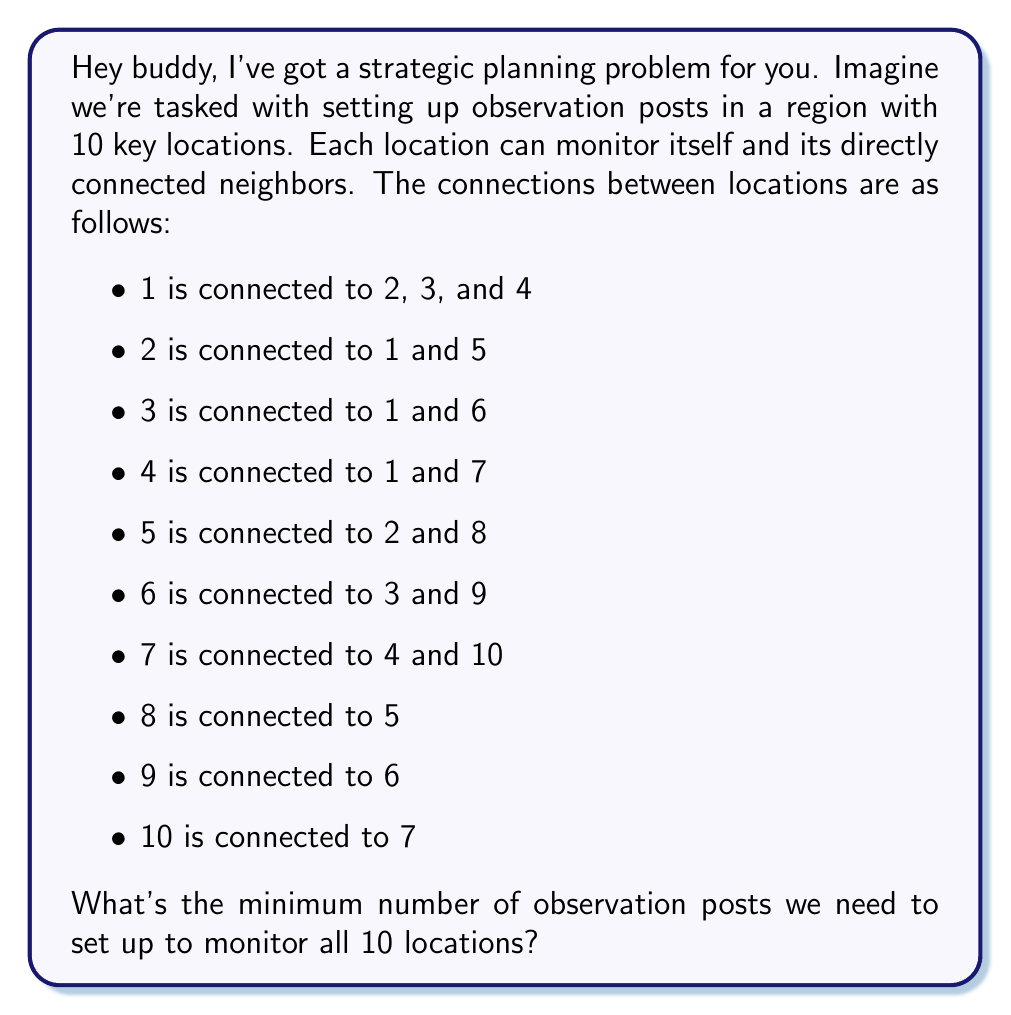Help me with this question. Alright, let's break this down step-by-step, just like we used to plan our missions:

1) This problem is a classic example of the Minimum Dominating Set problem in graph theory. We need to find the smallest set of vertices (locations) such that every vertex in the graph is either in the set or adjacent to a vertex in the set.

2) Let's visualize the graph:

[asy]
unitsize(0.5cm);
pair[] p = {(0,0),(3,3),(-3,3),(3,-3),(-3,-3),(6,6),(-6,6),(6,-6),(-6,-6),(0,-6)};
for(int i=0; i<10; ++i) {
  dot(p[i]);
  label("$" + string(i+1) + "$", p[i], E);
}
draw(p[0]--p[1]--p[4]--p[7]--p[0]--p[2]--p[5]--p[8]);
draw(p[0]--p[3]--p[6]--p[9]);
[/asy]

3) We can see that vertices 1, 5, 6, and 10 form a dominating set. Let's prove this is minimal:

   - 1 covers itself, 2, 3, and 4
   - 5 covers itself and 8
   - 6 covers itself and 9
   - 10 covers itself and 7

4) We can't remove any of these without leaving some vertex uncovered:
   - If we remove 1, vertices 2, 3, and 4 become uncovered
   - If we remove 5, vertex 8 becomes uncovered
   - If we remove 6, vertex 9 becomes uncovered
   - If we remove 10, vertex 7 becomes uncovered

5) We also can't replace this set with a smaller one. For example:
   - Vertex 1 alone can't cover 8, 9, and 10
   - Any set of 3 vertices will leave at least one vertex uncovered

Therefore, the minimum number of observation posts needed is 4.
Answer: 4 observation posts 